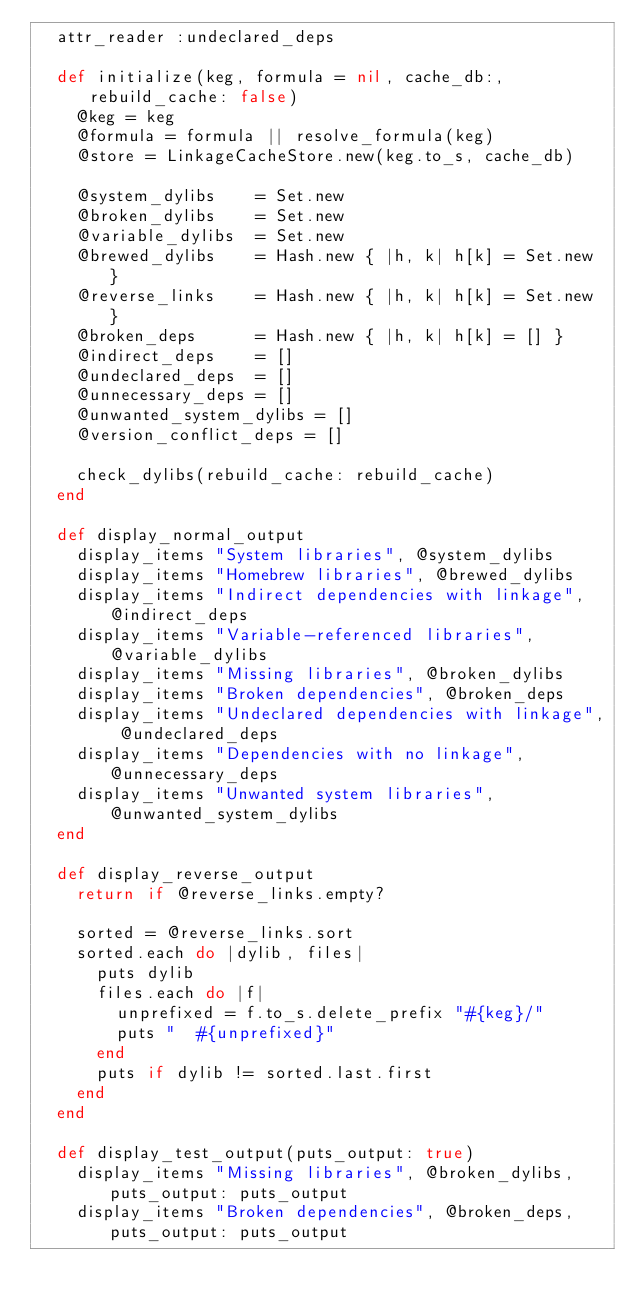Convert code to text. <code><loc_0><loc_0><loc_500><loc_500><_Ruby_>  attr_reader :undeclared_deps

  def initialize(keg, formula = nil, cache_db:, rebuild_cache: false)
    @keg = keg
    @formula = formula || resolve_formula(keg)
    @store = LinkageCacheStore.new(keg.to_s, cache_db)

    @system_dylibs    = Set.new
    @broken_dylibs    = Set.new
    @variable_dylibs  = Set.new
    @brewed_dylibs    = Hash.new { |h, k| h[k] = Set.new }
    @reverse_links    = Hash.new { |h, k| h[k] = Set.new }
    @broken_deps      = Hash.new { |h, k| h[k] = [] }
    @indirect_deps    = []
    @undeclared_deps  = []
    @unnecessary_deps = []
    @unwanted_system_dylibs = []
    @version_conflict_deps = []

    check_dylibs(rebuild_cache: rebuild_cache)
  end

  def display_normal_output
    display_items "System libraries", @system_dylibs
    display_items "Homebrew libraries", @brewed_dylibs
    display_items "Indirect dependencies with linkage", @indirect_deps
    display_items "Variable-referenced libraries", @variable_dylibs
    display_items "Missing libraries", @broken_dylibs
    display_items "Broken dependencies", @broken_deps
    display_items "Undeclared dependencies with linkage", @undeclared_deps
    display_items "Dependencies with no linkage", @unnecessary_deps
    display_items "Unwanted system libraries", @unwanted_system_dylibs
  end

  def display_reverse_output
    return if @reverse_links.empty?

    sorted = @reverse_links.sort
    sorted.each do |dylib, files|
      puts dylib
      files.each do |f|
        unprefixed = f.to_s.delete_prefix "#{keg}/"
        puts "  #{unprefixed}"
      end
      puts if dylib != sorted.last.first
    end
  end

  def display_test_output(puts_output: true)
    display_items "Missing libraries", @broken_dylibs, puts_output: puts_output
    display_items "Broken dependencies", @broken_deps, puts_output: puts_output</code> 